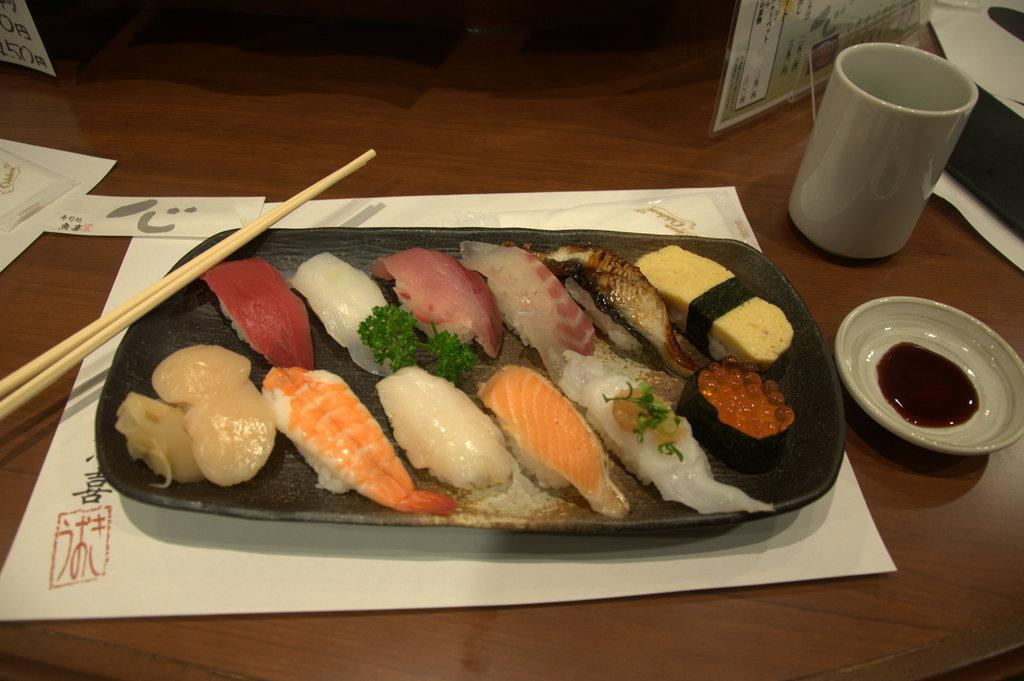What is on the plate that is visible on the table in the image? There is a plate with different kinds of food on the table in the image. What utensil is present in the image? Chopsticks are in the image. What type of container is visible in the image? There is a glass in the image. What other plate can be seen in the image? There is a small plate in the image. What piece of furniture is visible in the image? The table is visible in the image. What direction is the bell facing in the image? There is no bell present in the image. 